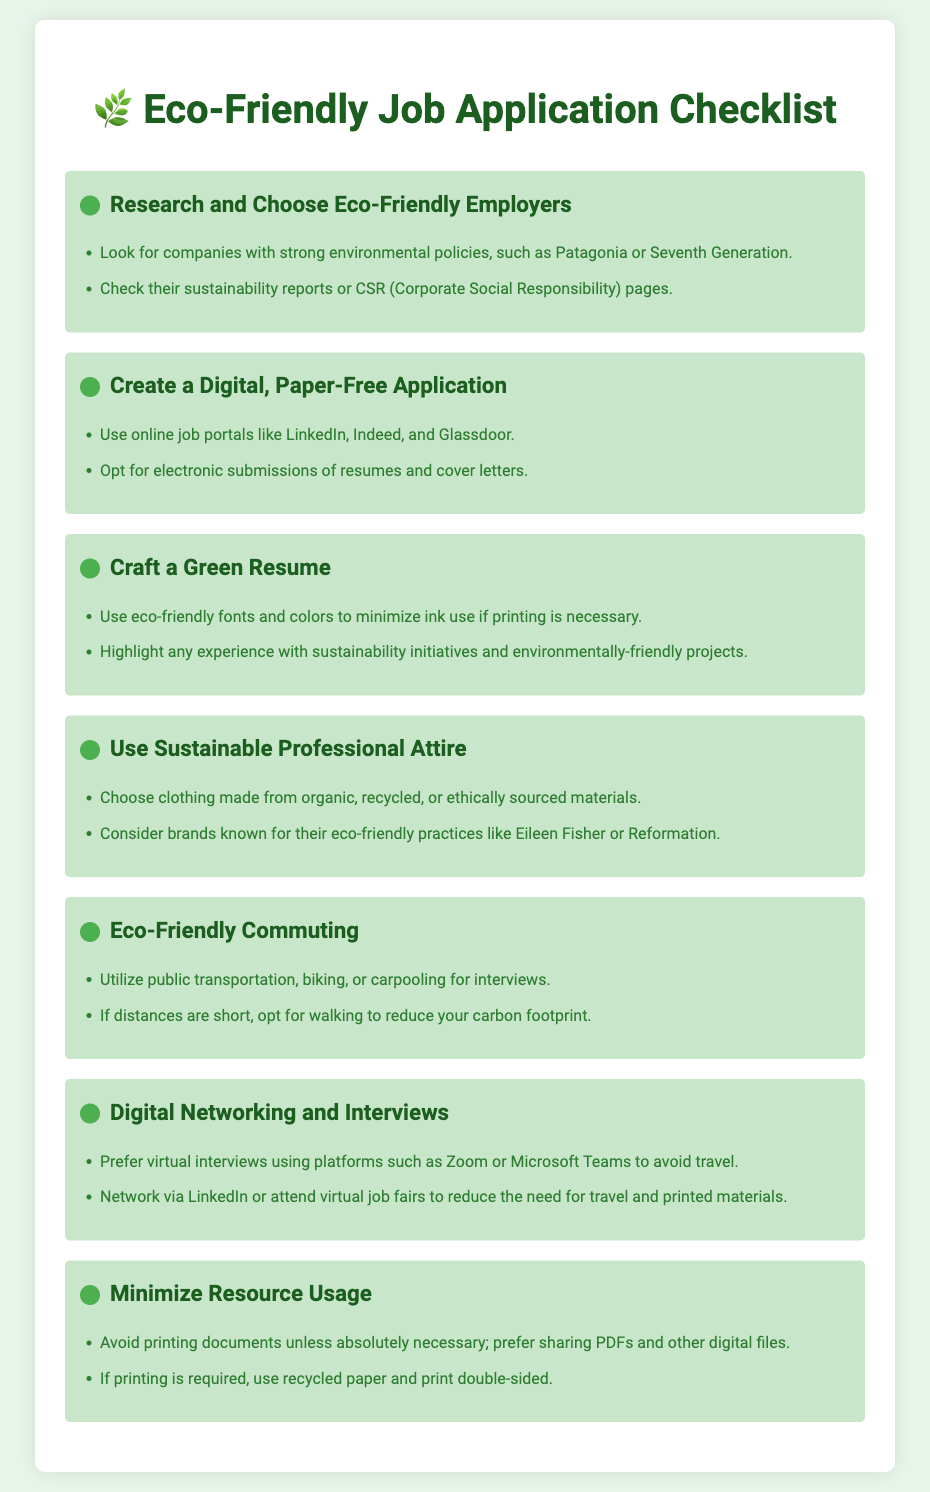What companies are mentioned as eco-friendly employers? The document lists Patagonia and Seventh Generation as examples of eco-friendly employers.
Answer: Patagonia, Seventh Generation What method does the checklist suggest for submitting applications? The checklist recommends opting for electronic submissions of resumes and cover letters to create a paper-free application.
Answer: Electronic submissions Which materials should sustainable professional attire be made from? The checklist advises choosing clothing made from organic, recycled, or ethically sourced materials.
Answer: Organic, recycled, ethically sourced What commuting options are recommended for interviews? The document suggests using public transportation, biking, or carpooling as eco-friendly commuting options.
Answer: Public transportation, biking, carpooling How should resumes be printed if necessary? The checklist states that if printing is required, use recycled paper and print double-sided.
Answer: Recycled paper, double-sided What platforms are suggested for virtual interviews? The document mentions using Zoom or Microsoft Teams for virtual interviews to avoid travel.
Answer: Zoom, Microsoft Teams What type of networking does the checklist recommend? The checklist recommends networking via LinkedIn or attending virtual job fairs to reduce travel needs.
Answer: LinkedIn, virtual job fairs What is emphasized in the checklist about document printing? It emphasizes avoiding printing documents unless absolutely necessary, preferring digital sharing instead.
Answer: Avoid printing What does the checklist state about highlighting experience? It suggests highlighting experience with sustainability initiatives and environmentally-friendly projects on your resume.
Answer: Sustainability initiatives, environmentally-friendly projects 